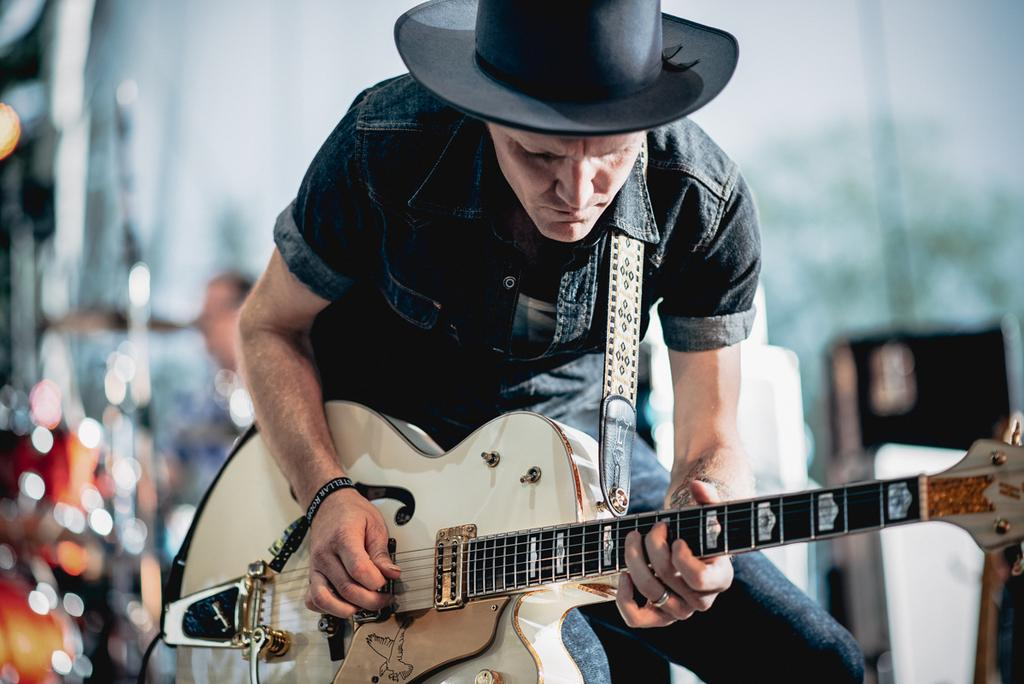What is the man in the image doing? The man is playing the guitar in the image. How is the man playing the guitar? The man is using his hand to play the guitar. What accessory is the man wearing on his head? A: The man is wearing a cap on his head. What is the man's father doing in the image? There is no mention of the man's father in the image, so it cannot be determined what he might be doing. 